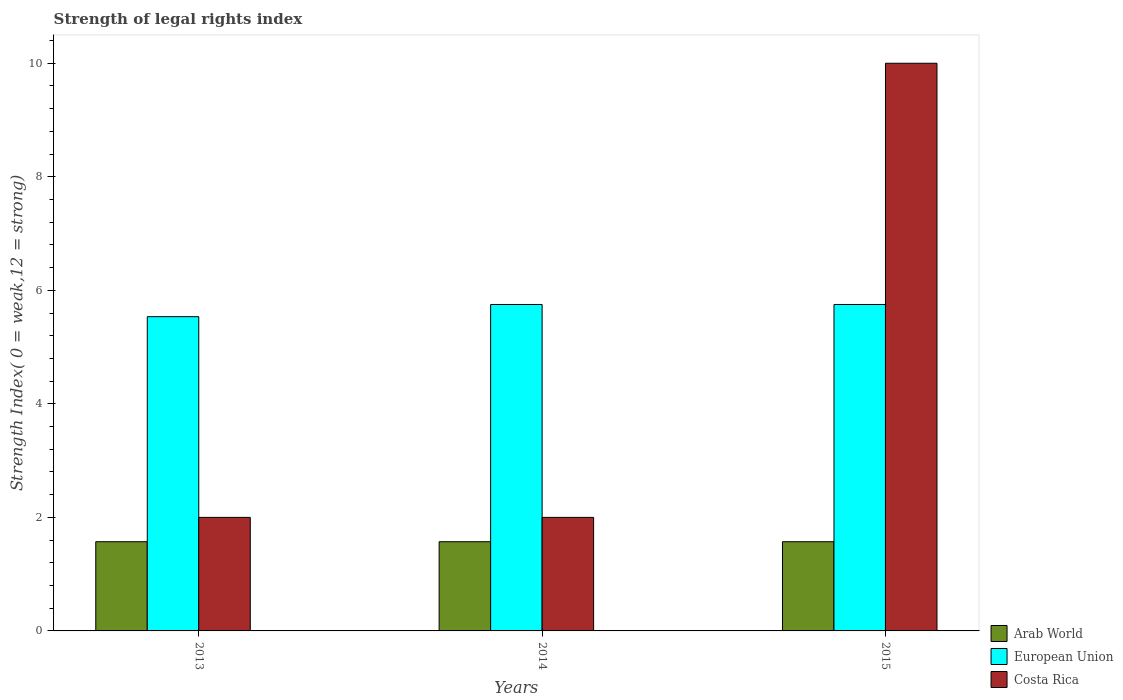How many different coloured bars are there?
Keep it short and to the point. 3. How many groups of bars are there?
Give a very brief answer. 3. How many bars are there on the 3rd tick from the left?
Ensure brevity in your answer.  3. How many bars are there on the 1st tick from the right?
Make the answer very short. 3. In how many cases, is the number of bars for a given year not equal to the number of legend labels?
Keep it short and to the point. 0. What is the strength index in Costa Rica in 2013?
Offer a very short reply. 2. Across all years, what is the maximum strength index in Costa Rica?
Your answer should be very brief. 10. Across all years, what is the minimum strength index in European Union?
Your response must be concise. 5.54. In which year was the strength index in Costa Rica maximum?
Keep it short and to the point. 2015. In which year was the strength index in Costa Rica minimum?
Your answer should be compact. 2013. What is the total strength index in European Union in the graph?
Provide a short and direct response. 17.04. What is the difference between the strength index in Costa Rica in 2013 and that in 2014?
Your answer should be compact. 0. What is the difference between the strength index in European Union in 2015 and the strength index in Costa Rica in 2014?
Make the answer very short. 3.75. What is the average strength index in Arab World per year?
Your answer should be very brief. 1.57. In the year 2013, what is the difference between the strength index in Costa Rica and strength index in European Union?
Keep it short and to the point. -3.54. In how many years, is the strength index in European Union greater than 4.8?
Offer a terse response. 3. What is the ratio of the strength index in European Union in 2013 to that in 2014?
Keep it short and to the point. 0.96. What is the difference between the highest and the second highest strength index in European Union?
Offer a terse response. 0. What is the difference between the highest and the lowest strength index in European Union?
Make the answer very short. 0.21. In how many years, is the strength index in European Union greater than the average strength index in European Union taken over all years?
Ensure brevity in your answer.  2. Is the sum of the strength index in Arab World in 2014 and 2015 greater than the maximum strength index in European Union across all years?
Offer a very short reply. No. What does the 2nd bar from the left in 2013 represents?
Offer a very short reply. European Union. Are all the bars in the graph horizontal?
Your answer should be compact. No. What is the difference between two consecutive major ticks on the Y-axis?
Provide a succinct answer. 2. Are the values on the major ticks of Y-axis written in scientific E-notation?
Your answer should be very brief. No. Where does the legend appear in the graph?
Ensure brevity in your answer.  Bottom right. How are the legend labels stacked?
Your response must be concise. Vertical. What is the title of the graph?
Your answer should be very brief. Strength of legal rights index. What is the label or title of the Y-axis?
Give a very brief answer. Strength Index( 0 = weak,12 = strong). What is the Strength Index( 0 = weak,12 = strong) in Arab World in 2013?
Keep it short and to the point. 1.57. What is the Strength Index( 0 = weak,12 = strong) of European Union in 2013?
Provide a short and direct response. 5.54. What is the Strength Index( 0 = weak,12 = strong) in Costa Rica in 2013?
Your response must be concise. 2. What is the Strength Index( 0 = weak,12 = strong) of Arab World in 2014?
Your answer should be very brief. 1.57. What is the Strength Index( 0 = weak,12 = strong) in European Union in 2014?
Your answer should be very brief. 5.75. What is the Strength Index( 0 = weak,12 = strong) of Arab World in 2015?
Offer a very short reply. 1.57. What is the Strength Index( 0 = weak,12 = strong) of European Union in 2015?
Offer a very short reply. 5.75. Across all years, what is the maximum Strength Index( 0 = weak,12 = strong) of Arab World?
Provide a short and direct response. 1.57. Across all years, what is the maximum Strength Index( 0 = weak,12 = strong) in European Union?
Offer a very short reply. 5.75. Across all years, what is the maximum Strength Index( 0 = weak,12 = strong) in Costa Rica?
Ensure brevity in your answer.  10. Across all years, what is the minimum Strength Index( 0 = weak,12 = strong) in Arab World?
Your answer should be very brief. 1.57. Across all years, what is the minimum Strength Index( 0 = weak,12 = strong) of European Union?
Ensure brevity in your answer.  5.54. What is the total Strength Index( 0 = weak,12 = strong) of Arab World in the graph?
Make the answer very short. 4.71. What is the total Strength Index( 0 = weak,12 = strong) in European Union in the graph?
Your answer should be very brief. 17.04. What is the difference between the Strength Index( 0 = weak,12 = strong) of Arab World in 2013 and that in 2014?
Your answer should be very brief. 0. What is the difference between the Strength Index( 0 = weak,12 = strong) in European Union in 2013 and that in 2014?
Ensure brevity in your answer.  -0.21. What is the difference between the Strength Index( 0 = weak,12 = strong) of Costa Rica in 2013 and that in 2014?
Make the answer very short. 0. What is the difference between the Strength Index( 0 = weak,12 = strong) of Arab World in 2013 and that in 2015?
Your response must be concise. 0. What is the difference between the Strength Index( 0 = weak,12 = strong) in European Union in 2013 and that in 2015?
Offer a terse response. -0.21. What is the difference between the Strength Index( 0 = weak,12 = strong) of Costa Rica in 2014 and that in 2015?
Provide a succinct answer. -8. What is the difference between the Strength Index( 0 = weak,12 = strong) of Arab World in 2013 and the Strength Index( 0 = weak,12 = strong) of European Union in 2014?
Provide a succinct answer. -4.18. What is the difference between the Strength Index( 0 = weak,12 = strong) of Arab World in 2013 and the Strength Index( 0 = weak,12 = strong) of Costa Rica in 2014?
Ensure brevity in your answer.  -0.43. What is the difference between the Strength Index( 0 = weak,12 = strong) in European Union in 2013 and the Strength Index( 0 = weak,12 = strong) in Costa Rica in 2014?
Offer a terse response. 3.54. What is the difference between the Strength Index( 0 = weak,12 = strong) of Arab World in 2013 and the Strength Index( 0 = weak,12 = strong) of European Union in 2015?
Offer a terse response. -4.18. What is the difference between the Strength Index( 0 = weak,12 = strong) of Arab World in 2013 and the Strength Index( 0 = weak,12 = strong) of Costa Rica in 2015?
Your answer should be compact. -8.43. What is the difference between the Strength Index( 0 = weak,12 = strong) of European Union in 2013 and the Strength Index( 0 = weak,12 = strong) of Costa Rica in 2015?
Your response must be concise. -4.46. What is the difference between the Strength Index( 0 = weak,12 = strong) of Arab World in 2014 and the Strength Index( 0 = weak,12 = strong) of European Union in 2015?
Make the answer very short. -4.18. What is the difference between the Strength Index( 0 = weak,12 = strong) in Arab World in 2014 and the Strength Index( 0 = weak,12 = strong) in Costa Rica in 2015?
Provide a succinct answer. -8.43. What is the difference between the Strength Index( 0 = weak,12 = strong) in European Union in 2014 and the Strength Index( 0 = weak,12 = strong) in Costa Rica in 2015?
Keep it short and to the point. -4.25. What is the average Strength Index( 0 = weak,12 = strong) of Arab World per year?
Offer a very short reply. 1.57. What is the average Strength Index( 0 = weak,12 = strong) of European Union per year?
Your response must be concise. 5.68. What is the average Strength Index( 0 = weak,12 = strong) of Costa Rica per year?
Give a very brief answer. 4.67. In the year 2013, what is the difference between the Strength Index( 0 = weak,12 = strong) of Arab World and Strength Index( 0 = weak,12 = strong) of European Union?
Provide a short and direct response. -3.96. In the year 2013, what is the difference between the Strength Index( 0 = weak,12 = strong) in Arab World and Strength Index( 0 = weak,12 = strong) in Costa Rica?
Provide a short and direct response. -0.43. In the year 2013, what is the difference between the Strength Index( 0 = weak,12 = strong) of European Union and Strength Index( 0 = weak,12 = strong) of Costa Rica?
Make the answer very short. 3.54. In the year 2014, what is the difference between the Strength Index( 0 = weak,12 = strong) in Arab World and Strength Index( 0 = weak,12 = strong) in European Union?
Provide a short and direct response. -4.18. In the year 2014, what is the difference between the Strength Index( 0 = weak,12 = strong) in Arab World and Strength Index( 0 = weak,12 = strong) in Costa Rica?
Keep it short and to the point. -0.43. In the year 2014, what is the difference between the Strength Index( 0 = weak,12 = strong) in European Union and Strength Index( 0 = weak,12 = strong) in Costa Rica?
Your answer should be very brief. 3.75. In the year 2015, what is the difference between the Strength Index( 0 = weak,12 = strong) in Arab World and Strength Index( 0 = weak,12 = strong) in European Union?
Offer a terse response. -4.18. In the year 2015, what is the difference between the Strength Index( 0 = weak,12 = strong) in Arab World and Strength Index( 0 = weak,12 = strong) in Costa Rica?
Your answer should be very brief. -8.43. In the year 2015, what is the difference between the Strength Index( 0 = weak,12 = strong) of European Union and Strength Index( 0 = weak,12 = strong) of Costa Rica?
Keep it short and to the point. -4.25. What is the ratio of the Strength Index( 0 = weak,12 = strong) in Arab World in 2013 to that in 2014?
Your answer should be compact. 1. What is the ratio of the Strength Index( 0 = weak,12 = strong) of European Union in 2013 to that in 2014?
Your answer should be very brief. 0.96. What is the ratio of the Strength Index( 0 = weak,12 = strong) in European Union in 2013 to that in 2015?
Your answer should be very brief. 0.96. What is the difference between the highest and the lowest Strength Index( 0 = weak,12 = strong) of European Union?
Offer a terse response. 0.21. 